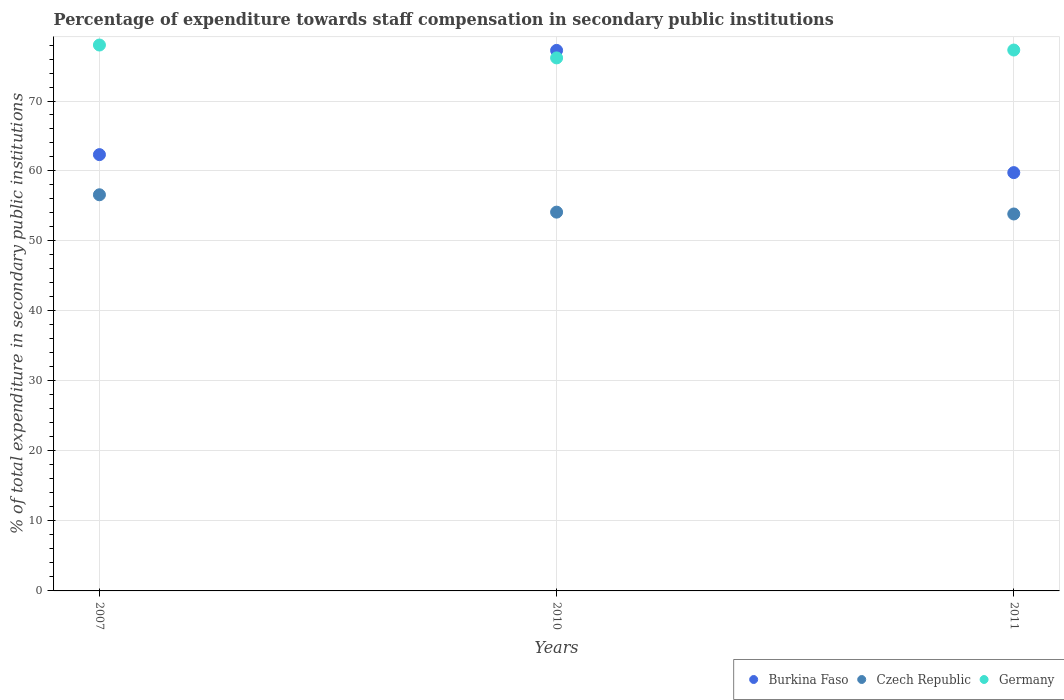How many different coloured dotlines are there?
Your answer should be compact. 3. What is the percentage of expenditure towards staff compensation in Burkina Faso in 2010?
Provide a short and direct response. 77.23. Across all years, what is the maximum percentage of expenditure towards staff compensation in Germany?
Keep it short and to the point. 78. Across all years, what is the minimum percentage of expenditure towards staff compensation in Burkina Faso?
Your answer should be very brief. 59.77. In which year was the percentage of expenditure towards staff compensation in Czech Republic maximum?
Ensure brevity in your answer.  2007. In which year was the percentage of expenditure towards staff compensation in Burkina Faso minimum?
Offer a very short reply. 2011. What is the total percentage of expenditure towards staff compensation in Germany in the graph?
Make the answer very short. 231.44. What is the difference between the percentage of expenditure towards staff compensation in Germany in 2007 and that in 2011?
Your response must be concise. 0.72. What is the difference between the percentage of expenditure towards staff compensation in Germany in 2010 and the percentage of expenditure towards staff compensation in Czech Republic in 2007?
Provide a succinct answer. 19.56. What is the average percentage of expenditure towards staff compensation in Burkina Faso per year?
Offer a very short reply. 66.45. In the year 2010, what is the difference between the percentage of expenditure towards staff compensation in Germany and percentage of expenditure towards staff compensation in Burkina Faso?
Provide a succinct answer. -1.07. What is the ratio of the percentage of expenditure towards staff compensation in Czech Republic in 2007 to that in 2011?
Offer a very short reply. 1.05. What is the difference between the highest and the second highest percentage of expenditure towards staff compensation in Czech Republic?
Your answer should be very brief. 2.48. What is the difference between the highest and the lowest percentage of expenditure towards staff compensation in Czech Republic?
Make the answer very short. 2.74. Is it the case that in every year, the sum of the percentage of expenditure towards staff compensation in Germany and percentage of expenditure towards staff compensation in Burkina Faso  is greater than the percentage of expenditure towards staff compensation in Czech Republic?
Keep it short and to the point. Yes. How many dotlines are there?
Your response must be concise. 3. Are the values on the major ticks of Y-axis written in scientific E-notation?
Give a very brief answer. No. Where does the legend appear in the graph?
Your response must be concise. Bottom right. What is the title of the graph?
Give a very brief answer. Percentage of expenditure towards staff compensation in secondary public institutions. What is the label or title of the Y-axis?
Provide a succinct answer. % of total expenditure in secondary public institutions. What is the % of total expenditure in secondary public institutions of Burkina Faso in 2007?
Your answer should be very brief. 62.34. What is the % of total expenditure in secondary public institutions of Czech Republic in 2007?
Your answer should be very brief. 56.6. What is the % of total expenditure in secondary public institutions in Germany in 2007?
Keep it short and to the point. 78. What is the % of total expenditure in secondary public institutions of Burkina Faso in 2010?
Your answer should be compact. 77.23. What is the % of total expenditure in secondary public institutions of Czech Republic in 2010?
Provide a succinct answer. 54.12. What is the % of total expenditure in secondary public institutions of Germany in 2010?
Keep it short and to the point. 76.16. What is the % of total expenditure in secondary public institutions in Burkina Faso in 2011?
Ensure brevity in your answer.  59.77. What is the % of total expenditure in secondary public institutions of Czech Republic in 2011?
Keep it short and to the point. 53.86. What is the % of total expenditure in secondary public institutions of Germany in 2011?
Give a very brief answer. 77.28. Across all years, what is the maximum % of total expenditure in secondary public institutions in Burkina Faso?
Your answer should be compact. 77.23. Across all years, what is the maximum % of total expenditure in secondary public institutions in Czech Republic?
Your answer should be compact. 56.6. Across all years, what is the maximum % of total expenditure in secondary public institutions in Germany?
Provide a short and direct response. 78. Across all years, what is the minimum % of total expenditure in secondary public institutions in Burkina Faso?
Give a very brief answer. 59.77. Across all years, what is the minimum % of total expenditure in secondary public institutions in Czech Republic?
Your answer should be very brief. 53.86. Across all years, what is the minimum % of total expenditure in secondary public institutions in Germany?
Your answer should be compact. 76.16. What is the total % of total expenditure in secondary public institutions in Burkina Faso in the graph?
Make the answer very short. 199.34. What is the total % of total expenditure in secondary public institutions in Czech Republic in the graph?
Provide a short and direct response. 164.58. What is the total % of total expenditure in secondary public institutions in Germany in the graph?
Provide a succinct answer. 231.44. What is the difference between the % of total expenditure in secondary public institutions in Burkina Faso in 2007 and that in 2010?
Provide a short and direct response. -14.89. What is the difference between the % of total expenditure in secondary public institutions of Czech Republic in 2007 and that in 2010?
Make the answer very short. 2.48. What is the difference between the % of total expenditure in secondary public institutions of Germany in 2007 and that in 2010?
Your answer should be very brief. 1.84. What is the difference between the % of total expenditure in secondary public institutions of Burkina Faso in 2007 and that in 2011?
Offer a terse response. 2.57. What is the difference between the % of total expenditure in secondary public institutions in Czech Republic in 2007 and that in 2011?
Your answer should be compact. 2.74. What is the difference between the % of total expenditure in secondary public institutions of Germany in 2007 and that in 2011?
Offer a terse response. 0.72. What is the difference between the % of total expenditure in secondary public institutions in Burkina Faso in 2010 and that in 2011?
Your answer should be compact. 17.46. What is the difference between the % of total expenditure in secondary public institutions of Czech Republic in 2010 and that in 2011?
Keep it short and to the point. 0.26. What is the difference between the % of total expenditure in secondary public institutions in Germany in 2010 and that in 2011?
Provide a succinct answer. -1.12. What is the difference between the % of total expenditure in secondary public institutions in Burkina Faso in 2007 and the % of total expenditure in secondary public institutions in Czech Republic in 2010?
Offer a terse response. 8.22. What is the difference between the % of total expenditure in secondary public institutions in Burkina Faso in 2007 and the % of total expenditure in secondary public institutions in Germany in 2010?
Keep it short and to the point. -13.82. What is the difference between the % of total expenditure in secondary public institutions in Czech Republic in 2007 and the % of total expenditure in secondary public institutions in Germany in 2010?
Offer a very short reply. -19.56. What is the difference between the % of total expenditure in secondary public institutions of Burkina Faso in 2007 and the % of total expenditure in secondary public institutions of Czech Republic in 2011?
Your answer should be very brief. 8.48. What is the difference between the % of total expenditure in secondary public institutions of Burkina Faso in 2007 and the % of total expenditure in secondary public institutions of Germany in 2011?
Your answer should be very brief. -14.95. What is the difference between the % of total expenditure in secondary public institutions in Czech Republic in 2007 and the % of total expenditure in secondary public institutions in Germany in 2011?
Your answer should be very brief. -20.68. What is the difference between the % of total expenditure in secondary public institutions in Burkina Faso in 2010 and the % of total expenditure in secondary public institutions in Czech Republic in 2011?
Ensure brevity in your answer.  23.37. What is the difference between the % of total expenditure in secondary public institutions in Burkina Faso in 2010 and the % of total expenditure in secondary public institutions in Germany in 2011?
Provide a short and direct response. -0.05. What is the difference between the % of total expenditure in secondary public institutions in Czech Republic in 2010 and the % of total expenditure in secondary public institutions in Germany in 2011?
Provide a succinct answer. -23.16. What is the average % of total expenditure in secondary public institutions of Burkina Faso per year?
Keep it short and to the point. 66.45. What is the average % of total expenditure in secondary public institutions of Czech Republic per year?
Offer a very short reply. 54.86. What is the average % of total expenditure in secondary public institutions in Germany per year?
Provide a short and direct response. 77.15. In the year 2007, what is the difference between the % of total expenditure in secondary public institutions in Burkina Faso and % of total expenditure in secondary public institutions in Czech Republic?
Ensure brevity in your answer.  5.74. In the year 2007, what is the difference between the % of total expenditure in secondary public institutions in Burkina Faso and % of total expenditure in secondary public institutions in Germany?
Provide a short and direct response. -15.66. In the year 2007, what is the difference between the % of total expenditure in secondary public institutions of Czech Republic and % of total expenditure in secondary public institutions of Germany?
Provide a short and direct response. -21.4. In the year 2010, what is the difference between the % of total expenditure in secondary public institutions in Burkina Faso and % of total expenditure in secondary public institutions in Czech Republic?
Ensure brevity in your answer.  23.11. In the year 2010, what is the difference between the % of total expenditure in secondary public institutions of Burkina Faso and % of total expenditure in secondary public institutions of Germany?
Provide a succinct answer. 1.07. In the year 2010, what is the difference between the % of total expenditure in secondary public institutions in Czech Republic and % of total expenditure in secondary public institutions in Germany?
Provide a succinct answer. -22.04. In the year 2011, what is the difference between the % of total expenditure in secondary public institutions in Burkina Faso and % of total expenditure in secondary public institutions in Czech Republic?
Provide a succinct answer. 5.91. In the year 2011, what is the difference between the % of total expenditure in secondary public institutions of Burkina Faso and % of total expenditure in secondary public institutions of Germany?
Keep it short and to the point. -17.51. In the year 2011, what is the difference between the % of total expenditure in secondary public institutions of Czech Republic and % of total expenditure in secondary public institutions of Germany?
Your response must be concise. -23.42. What is the ratio of the % of total expenditure in secondary public institutions of Burkina Faso in 2007 to that in 2010?
Make the answer very short. 0.81. What is the ratio of the % of total expenditure in secondary public institutions of Czech Republic in 2007 to that in 2010?
Offer a very short reply. 1.05. What is the ratio of the % of total expenditure in secondary public institutions of Germany in 2007 to that in 2010?
Offer a very short reply. 1.02. What is the ratio of the % of total expenditure in secondary public institutions in Burkina Faso in 2007 to that in 2011?
Offer a terse response. 1.04. What is the ratio of the % of total expenditure in secondary public institutions in Czech Republic in 2007 to that in 2011?
Your answer should be compact. 1.05. What is the ratio of the % of total expenditure in secondary public institutions in Germany in 2007 to that in 2011?
Your answer should be compact. 1.01. What is the ratio of the % of total expenditure in secondary public institutions of Burkina Faso in 2010 to that in 2011?
Keep it short and to the point. 1.29. What is the ratio of the % of total expenditure in secondary public institutions in Czech Republic in 2010 to that in 2011?
Provide a short and direct response. 1. What is the ratio of the % of total expenditure in secondary public institutions of Germany in 2010 to that in 2011?
Offer a very short reply. 0.99. What is the difference between the highest and the second highest % of total expenditure in secondary public institutions in Burkina Faso?
Ensure brevity in your answer.  14.89. What is the difference between the highest and the second highest % of total expenditure in secondary public institutions in Czech Republic?
Provide a succinct answer. 2.48. What is the difference between the highest and the second highest % of total expenditure in secondary public institutions in Germany?
Your answer should be compact. 0.72. What is the difference between the highest and the lowest % of total expenditure in secondary public institutions of Burkina Faso?
Ensure brevity in your answer.  17.46. What is the difference between the highest and the lowest % of total expenditure in secondary public institutions of Czech Republic?
Provide a succinct answer. 2.74. What is the difference between the highest and the lowest % of total expenditure in secondary public institutions of Germany?
Keep it short and to the point. 1.84. 